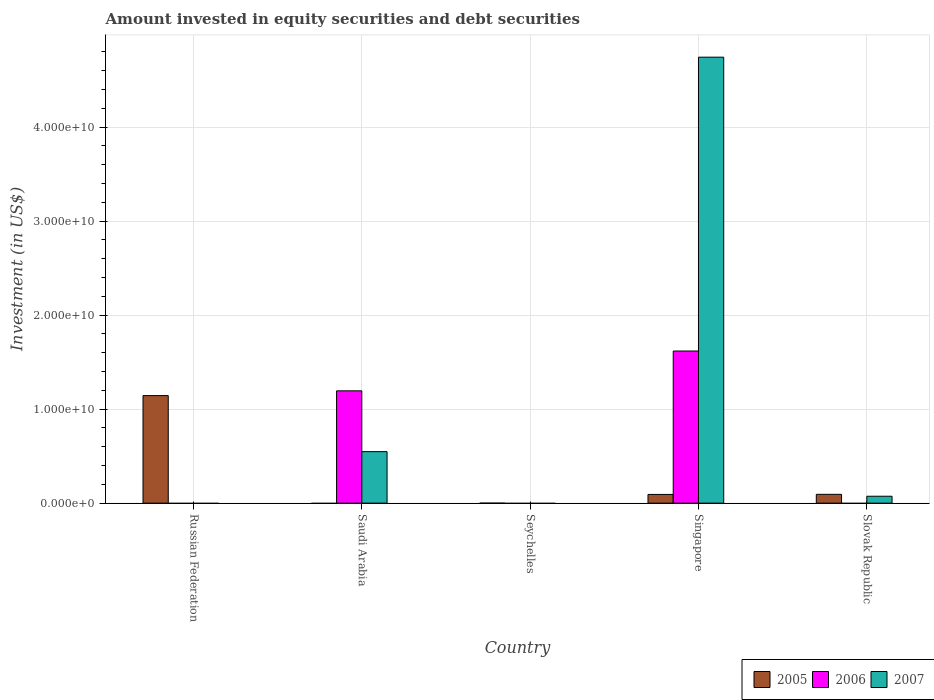Are the number of bars per tick equal to the number of legend labels?
Provide a succinct answer. No. How many bars are there on the 4th tick from the left?
Offer a very short reply. 3. What is the label of the 2nd group of bars from the left?
Your response must be concise. Saudi Arabia. What is the amount invested in equity securities and debt securities in 2006 in Singapore?
Provide a short and direct response. 1.62e+1. Across all countries, what is the maximum amount invested in equity securities and debt securities in 2006?
Ensure brevity in your answer.  1.62e+1. In which country was the amount invested in equity securities and debt securities in 2005 maximum?
Provide a succinct answer. Russian Federation. What is the total amount invested in equity securities and debt securities in 2006 in the graph?
Give a very brief answer. 2.81e+1. What is the difference between the amount invested in equity securities and debt securities in 2005 in Singapore and that in Slovak Republic?
Your answer should be very brief. -9.90e+06. What is the difference between the amount invested in equity securities and debt securities in 2005 in Saudi Arabia and the amount invested in equity securities and debt securities in 2007 in Singapore?
Provide a short and direct response. -4.74e+1. What is the average amount invested in equity securities and debt securities in 2006 per country?
Your answer should be very brief. 5.63e+09. What is the difference between the amount invested in equity securities and debt securities of/in 2007 and amount invested in equity securities and debt securities of/in 2005 in Slovak Republic?
Make the answer very short. -2.02e+08. In how many countries, is the amount invested in equity securities and debt securities in 2007 greater than 4000000000 US$?
Provide a short and direct response. 2. What is the difference between the highest and the second highest amount invested in equity securities and debt securities in 2007?
Your answer should be very brief. 4.20e+1. What is the difference between the highest and the lowest amount invested in equity securities and debt securities in 2007?
Your response must be concise. 4.74e+1. Is it the case that in every country, the sum of the amount invested in equity securities and debt securities in 2007 and amount invested in equity securities and debt securities in 2005 is greater than the amount invested in equity securities and debt securities in 2006?
Ensure brevity in your answer.  No. How many bars are there?
Provide a short and direct response. 8. How many countries are there in the graph?
Ensure brevity in your answer.  5. What is the difference between two consecutive major ticks on the Y-axis?
Your response must be concise. 1.00e+1. Does the graph contain grids?
Your answer should be very brief. Yes. Where does the legend appear in the graph?
Offer a very short reply. Bottom right. How many legend labels are there?
Offer a terse response. 3. What is the title of the graph?
Ensure brevity in your answer.  Amount invested in equity securities and debt securities. What is the label or title of the Y-axis?
Offer a terse response. Investment (in US$). What is the Investment (in US$) in 2005 in Russian Federation?
Ensure brevity in your answer.  1.14e+1. What is the Investment (in US$) of 2006 in Russian Federation?
Your answer should be compact. 0. What is the Investment (in US$) of 2006 in Saudi Arabia?
Make the answer very short. 1.19e+1. What is the Investment (in US$) of 2007 in Saudi Arabia?
Your answer should be compact. 5.48e+09. What is the Investment (in US$) of 2005 in Seychelles?
Keep it short and to the point. 0. What is the Investment (in US$) of 2007 in Seychelles?
Make the answer very short. 0. What is the Investment (in US$) in 2005 in Singapore?
Keep it short and to the point. 9.27e+08. What is the Investment (in US$) of 2006 in Singapore?
Give a very brief answer. 1.62e+1. What is the Investment (in US$) of 2007 in Singapore?
Offer a very short reply. 4.74e+1. What is the Investment (in US$) in 2005 in Slovak Republic?
Offer a very short reply. 9.37e+08. What is the Investment (in US$) of 2006 in Slovak Republic?
Provide a succinct answer. 0. What is the Investment (in US$) in 2007 in Slovak Republic?
Your answer should be very brief. 7.34e+08. Across all countries, what is the maximum Investment (in US$) of 2005?
Give a very brief answer. 1.14e+1. Across all countries, what is the maximum Investment (in US$) in 2006?
Provide a short and direct response. 1.62e+1. Across all countries, what is the maximum Investment (in US$) in 2007?
Give a very brief answer. 4.74e+1. What is the total Investment (in US$) of 2005 in the graph?
Provide a succinct answer. 1.33e+1. What is the total Investment (in US$) of 2006 in the graph?
Ensure brevity in your answer.  2.81e+1. What is the total Investment (in US$) of 2007 in the graph?
Provide a short and direct response. 5.37e+1. What is the difference between the Investment (in US$) in 2005 in Russian Federation and that in Singapore?
Ensure brevity in your answer.  1.05e+1. What is the difference between the Investment (in US$) of 2005 in Russian Federation and that in Slovak Republic?
Provide a short and direct response. 1.05e+1. What is the difference between the Investment (in US$) of 2006 in Saudi Arabia and that in Singapore?
Provide a succinct answer. -4.24e+09. What is the difference between the Investment (in US$) in 2007 in Saudi Arabia and that in Singapore?
Your answer should be very brief. -4.20e+1. What is the difference between the Investment (in US$) of 2007 in Saudi Arabia and that in Slovak Republic?
Make the answer very short. 4.75e+09. What is the difference between the Investment (in US$) of 2005 in Singapore and that in Slovak Republic?
Your answer should be compact. -9.90e+06. What is the difference between the Investment (in US$) in 2007 in Singapore and that in Slovak Republic?
Keep it short and to the point. 4.67e+1. What is the difference between the Investment (in US$) in 2005 in Russian Federation and the Investment (in US$) in 2006 in Saudi Arabia?
Give a very brief answer. -5.06e+08. What is the difference between the Investment (in US$) in 2005 in Russian Federation and the Investment (in US$) in 2007 in Saudi Arabia?
Your answer should be compact. 5.96e+09. What is the difference between the Investment (in US$) of 2005 in Russian Federation and the Investment (in US$) of 2006 in Singapore?
Provide a short and direct response. -4.74e+09. What is the difference between the Investment (in US$) of 2005 in Russian Federation and the Investment (in US$) of 2007 in Singapore?
Provide a short and direct response. -3.60e+1. What is the difference between the Investment (in US$) of 2005 in Russian Federation and the Investment (in US$) of 2007 in Slovak Republic?
Offer a terse response. 1.07e+1. What is the difference between the Investment (in US$) in 2006 in Saudi Arabia and the Investment (in US$) in 2007 in Singapore?
Your answer should be very brief. -3.55e+1. What is the difference between the Investment (in US$) in 2006 in Saudi Arabia and the Investment (in US$) in 2007 in Slovak Republic?
Ensure brevity in your answer.  1.12e+1. What is the difference between the Investment (in US$) in 2005 in Singapore and the Investment (in US$) in 2007 in Slovak Republic?
Provide a short and direct response. 1.92e+08. What is the difference between the Investment (in US$) of 2006 in Singapore and the Investment (in US$) of 2007 in Slovak Republic?
Keep it short and to the point. 1.55e+1. What is the average Investment (in US$) in 2005 per country?
Provide a succinct answer. 2.66e+09. What is the average Investment (in US$) in 2006 per country?
Provide a succinct answer. 5.63e+09. What is the average Investment (in US$) in 2007 per country?
Offer a terse response. 1.07e+1. What is the difference between the Investment (in US$) of 2006 and Investment (in US$) of 2007 in Saudi Arabia?
Your answer should be compact. 6.47e+09. What is the difference between the Investment (in US$) in 2005 and Investment (in US$) in 2006 in Singapore?
Keep it short and to the point. -1.53e+1. What is the difference between the Investment (in US$) of 2005 and Investment (in US$) of 2007 in Singapore?
Give a very brief answer. -4.65e+1. What is the difference between the Investment (in US$) of 2006 and Investment (in US$) of 2007 in Singapore?
Your answer should be compact. -3.13e+1. What is the difference between the Investment (in US$) of 2005 and Investment (in US$) of 2007 in Slovak Republic?
Give a very brief answer. 2.02e+08. What is the ratio of the Investment (in US$) in 2005 in Russian Federation to that in Singapore?
Provide a short and direct response. 12.35. What is the ratio of the Investment (in US$) of 2005 in Russian Federation to that in Slovak Republic?
Offer a very short reply. 12.22. What is the ratio of the Investment (in US$) in 2006 in Saudi Arabia to that in Singapore?
Your response must be concise. 0.74. What is the ratio of the Investment (in US$) of 2007 in Saudi Arabia to that in Singapore?
Provide a short and direct response. 0.12. What is the ratio of the Investment (in US$) of 2007 in Saudi Arabia to that in Slovak Republic?
Ensure brevity in your answer.  7.46. What is the ratio of the Investment (in US$) of 2007 in Singapore to that in Slovak Republic?
Offer a very short reply. 64.62. What is the difference between the highest and the second highest Investment (in US$) of 2005?
Your response must be concise. 1.05e+1. What is the difference between the highest and the second highest Investment (in US$) of 2007?
Keep it short and to the point. 4.20e+1. What is the difference between the highest and the lowest Investment (in US$) in 2005?
Provide a short and direct response. 1.14e+1. What is the difference between the highest and the lowest Investment (in US$) in 2006?
Keep it short and to the point. 1.62e+1. What is the difference between the highest and the lowest Investment (in US$) of 2007?
Provide a succinct answer. 4.74e+1. 